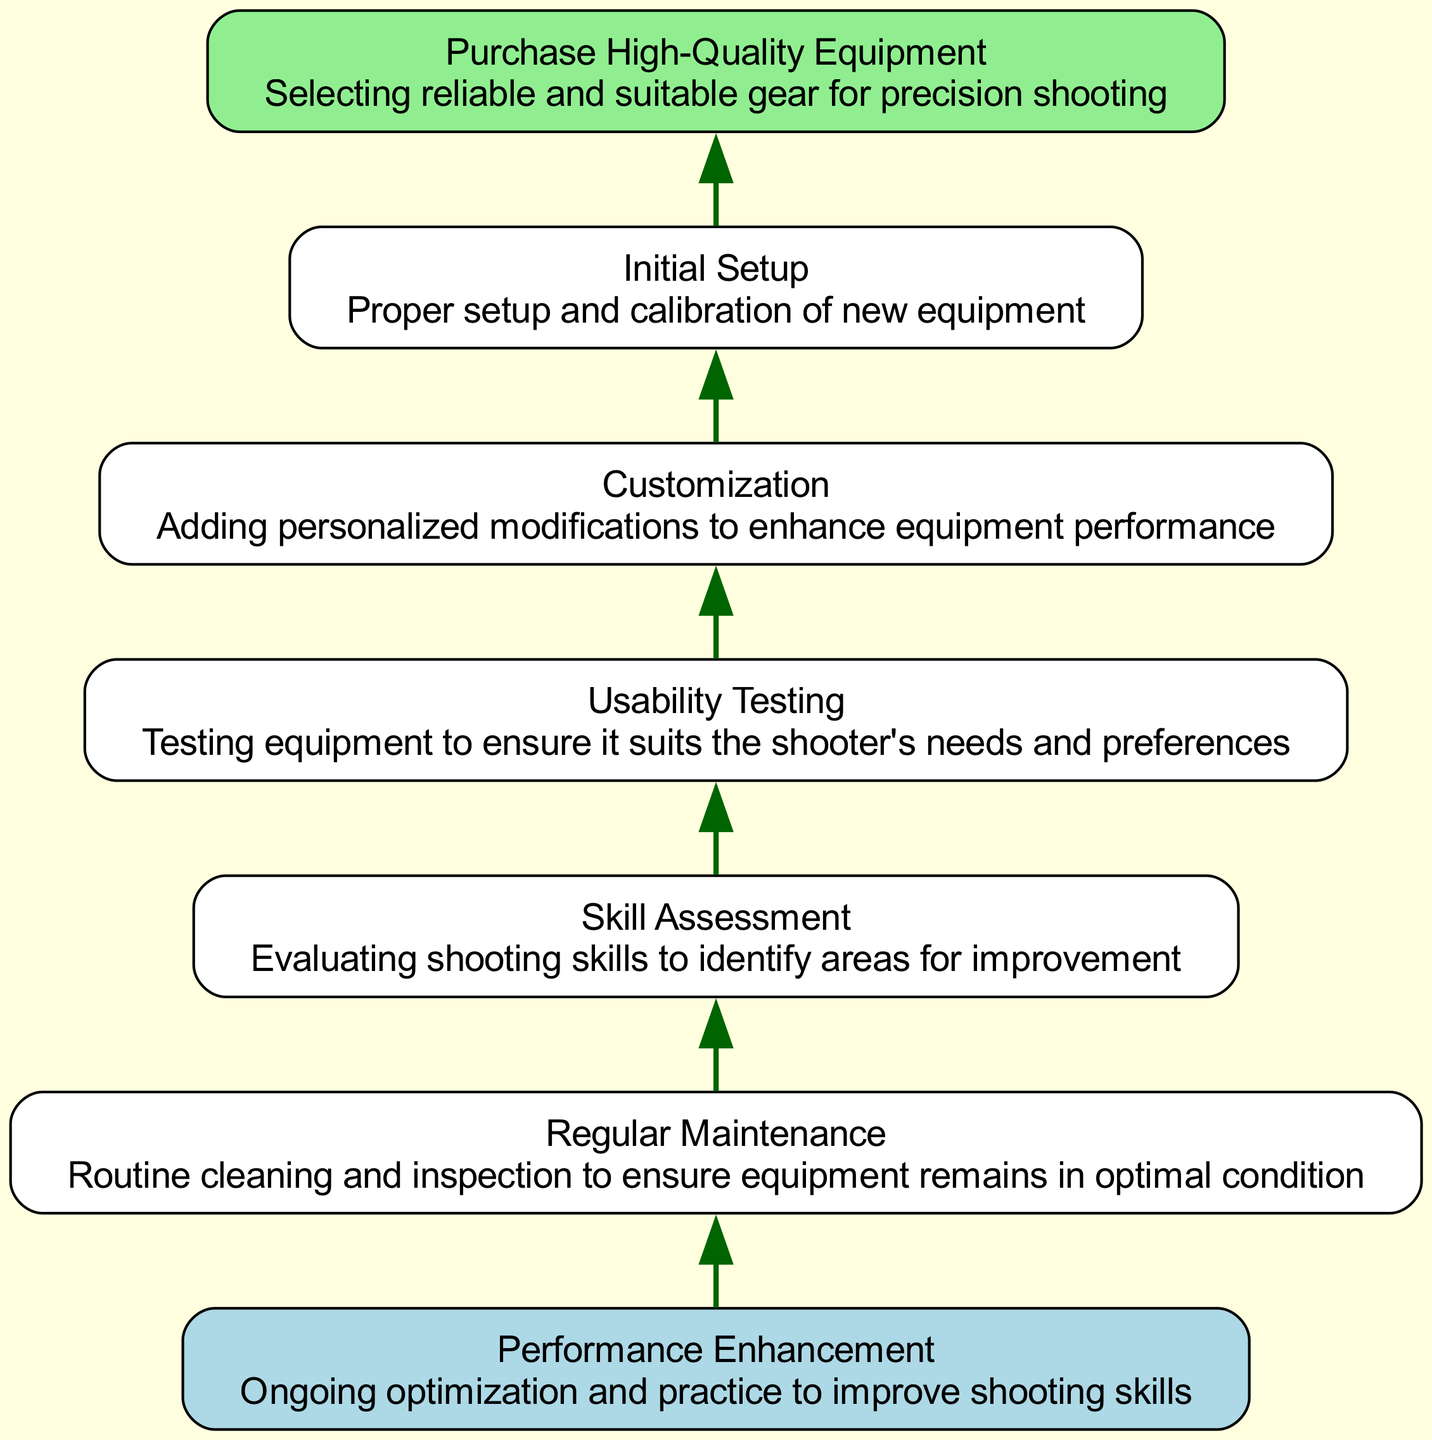What is the first step in the flowchart? The flowchart starts with "Purchase High-Quality Equipment". This is indicated as the starting node at the bottom of the diagram.
Answer: Purchase High-Quality Equipment How many total nodes are in the flowchart? By counting the nodes listed in the diagram (there are six mentioned), we determine that there are a total of six nodes in the flowchart.
Answer: 6 What type of node is "Regular Maintenance"? "Regular Maintenance" is classified as a "process" type node, which is indicated in its description in the diagram.
Answer: process What comes immediately after "Skill Assessment" in the flow? In the flowchart, "Usability Testing" comes immediately after "Skill Assessment," which can be seen in the connection from node 2 to node 3.
Answer: Usability Testing Which node is the final step in the process? The flowchart concludes with "Performance Enhancement," which is designated as the final node in the diagram, indicating the completion of the process.
Answer: Performance Enhancement What is the relationship between "Customization" and "Initial Setup"? The relationship is that "Customization" leads into "Initial Setup," as indicated by the connection arrow flowing from node 4 to node 5 in the diagram.
Answer: Customization leads to Initial Setup What is the primary purpose of "Skill Assessment"? The primary purpose of "Skill Assessment" is to evaluate shooting skills to identify areas for improvement, as described in its description within the diagram.
Answer: Evaluating shooting skills How many edges connect the nodes in this flowchart? There are a total of five edges in the flowchart, which connect the six nodes in a sequential manner from start to final step.
Answer: 5 What node leads to the final step in the flowchart? The node that leads to the final step "Performance Enhancement" is "Regular Maintenance," as indicated by the direct connection from node 1 to node 0.
Answer: Regular Maintenance 